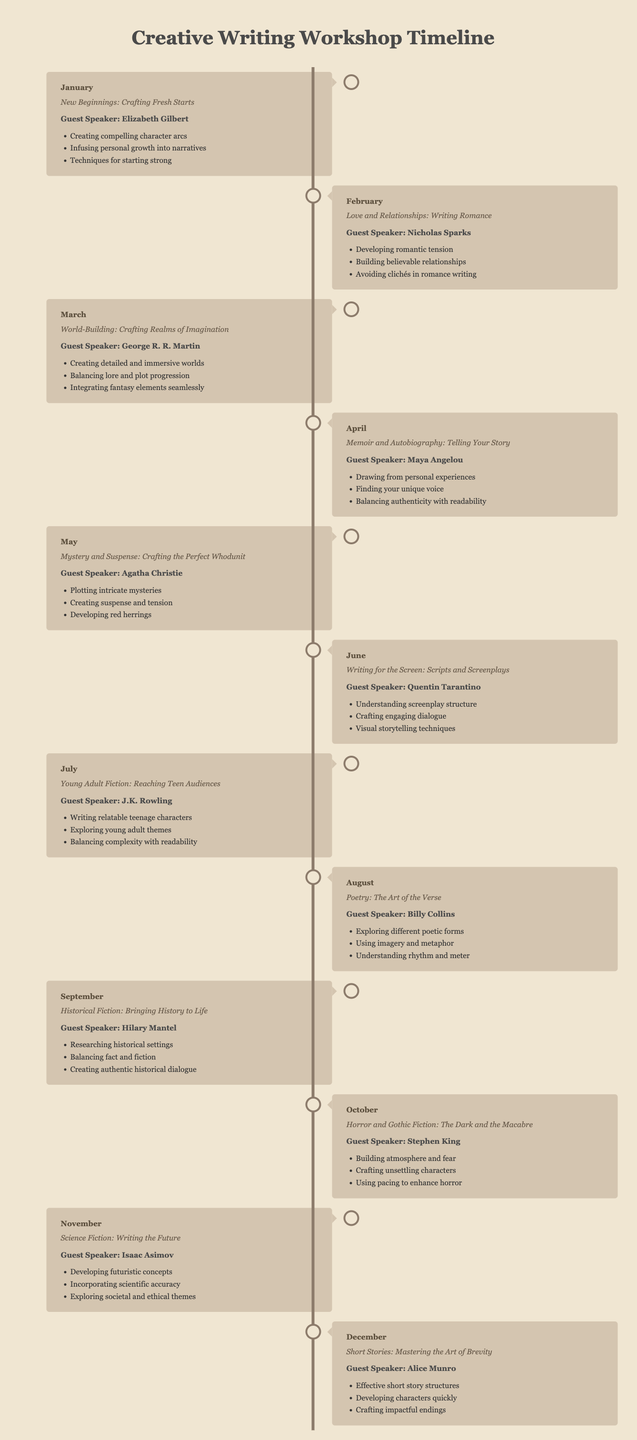What was the theme of the January workshop? The theme for January was "New Beginnings: Crafting Fresh Starts."
Answer: New Beginnings: Crafting Fresh Starts Who was the guest speaker in April? The guest speaker in April was Maya Angelou.
Answer: Maya Angelou How many months featured a guest speaker associated with romantic themes? The months with romantic themes featured a total of two guest speakers: Elizabeth Gilbert and Nicholas Sparks in January and February.
Answer: 2 Which month had a focus on Science Fiction? The focus on Science Fiction was in November.
Answer: November What topic did J.K. Rowling discuss in July? J.K. Rowling discussed Young Adult Fiction in July.
Answer: Young Adult Fiction Which speaker talked about crafting the perfect whodunit? Agatha Christie talked about crafting the perfect whodunit in May.
Answer: Agatha Christie What is the main focus of the August workshop? The main focus of the August workshop was on poetry.
Answer: Poetry How many themes throughout the year focused on storytelling based on personal experiences? There were two themes focusing on personal experiences: Memoir and Autobiography in April and the emphasis on authenticity in various genres.
Answer: 2 